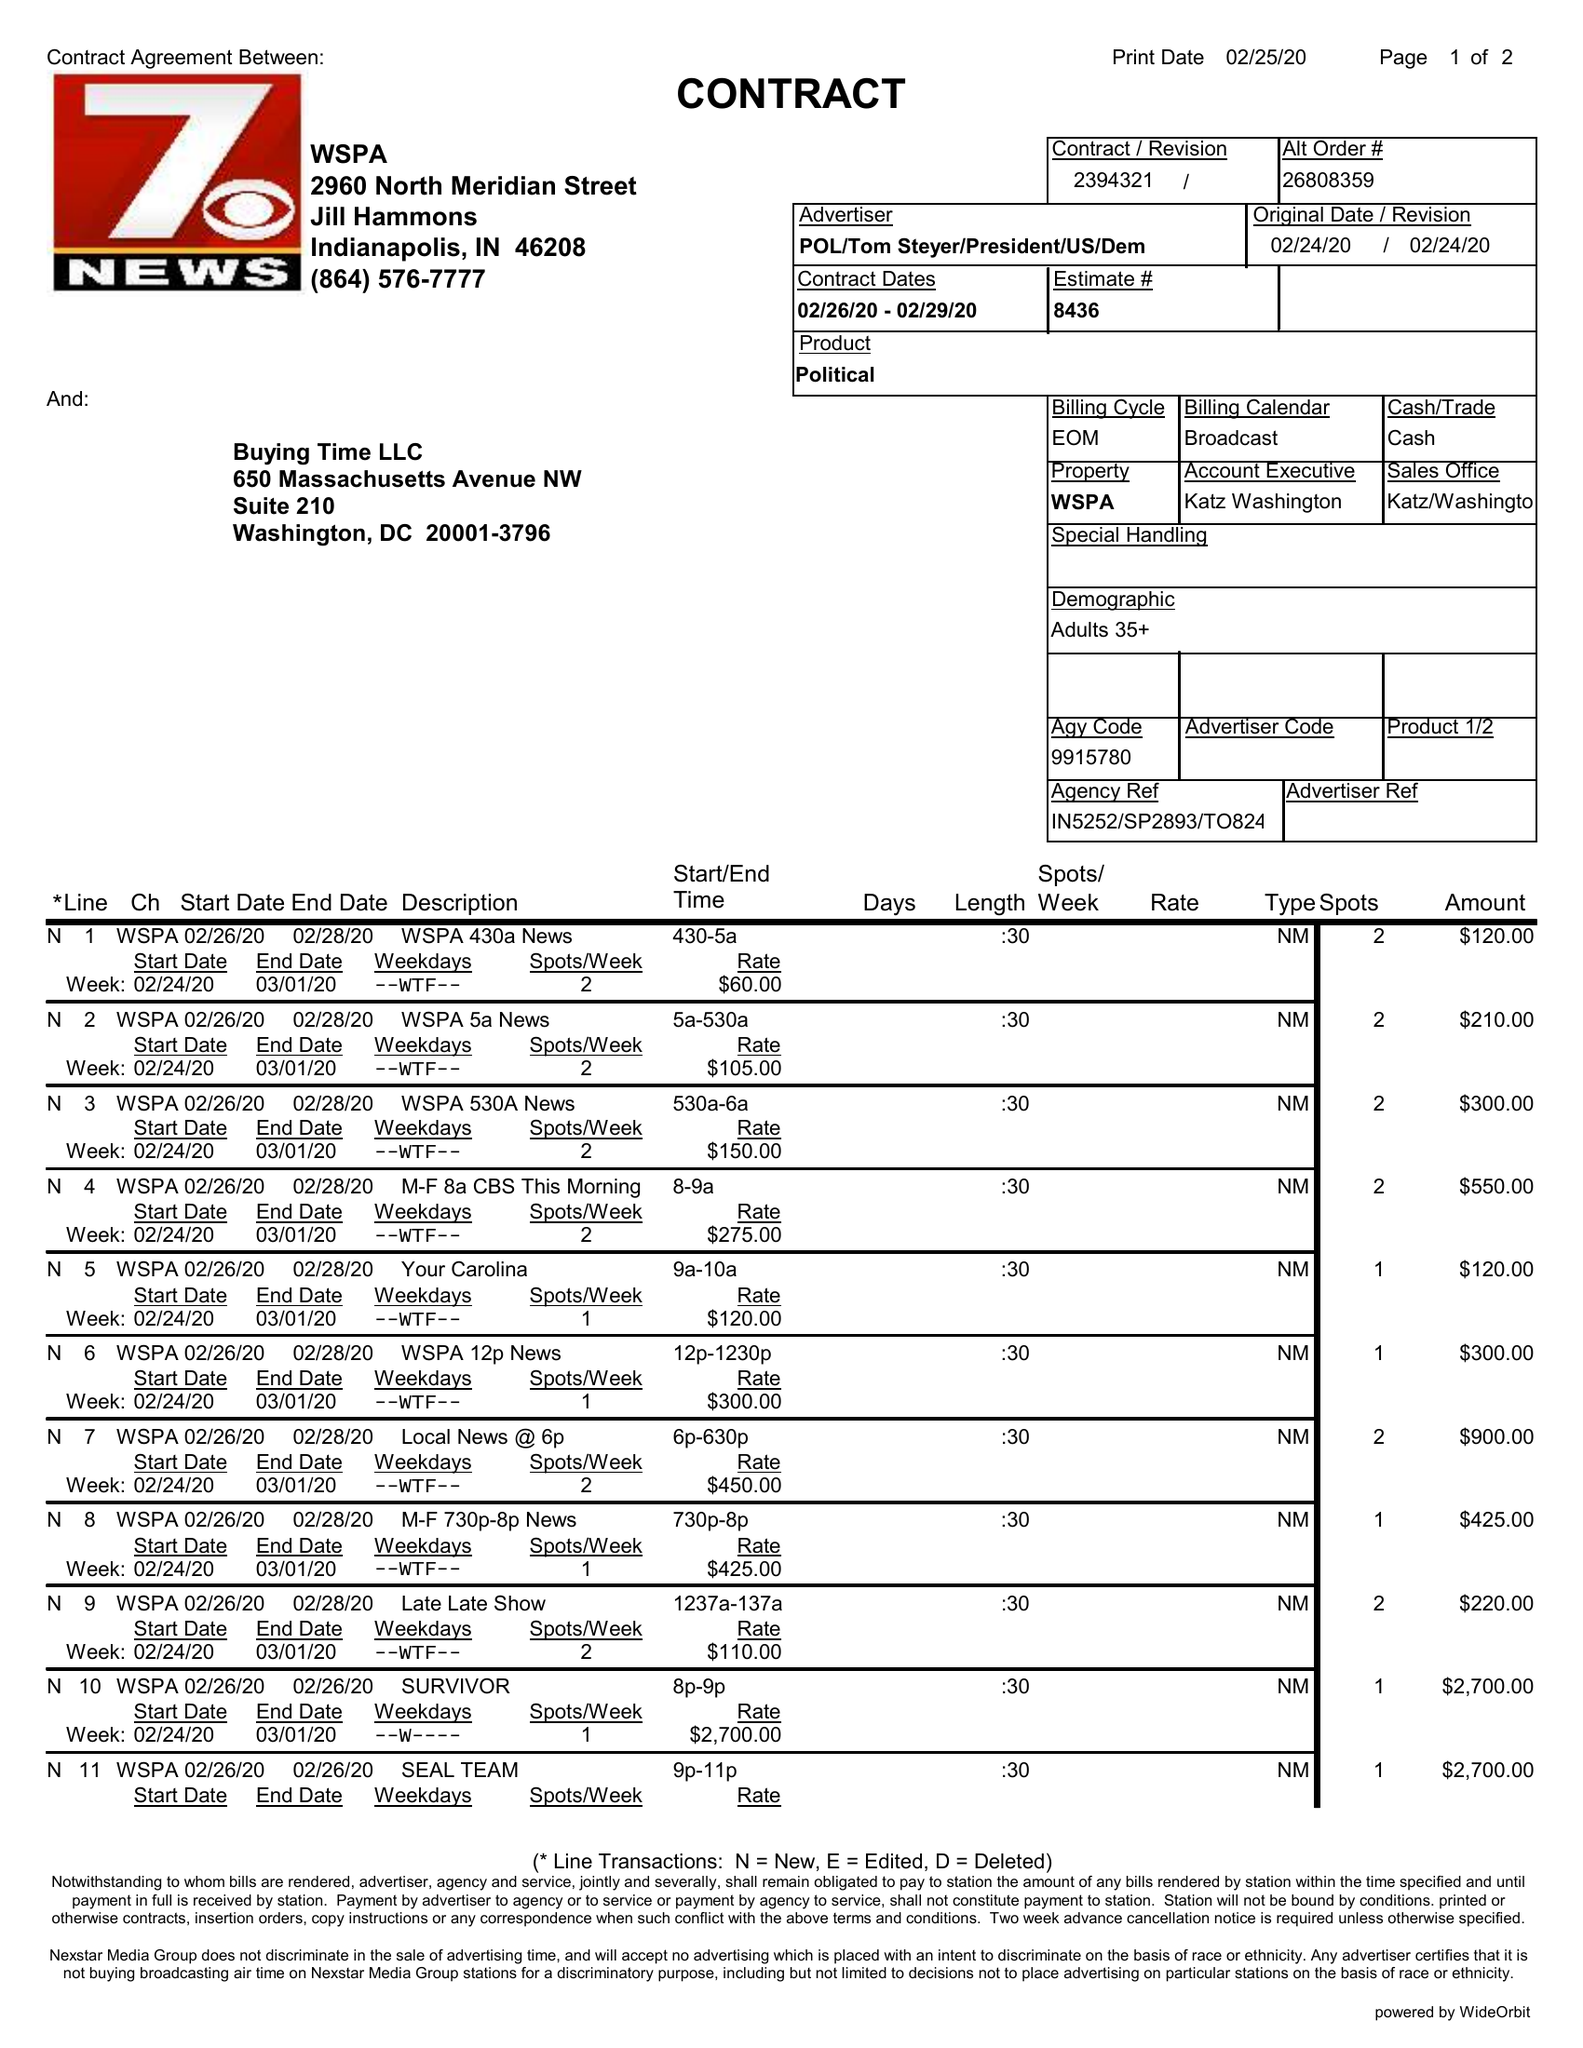What is the value for the gross_amount?
Answer the question using a single word or phrase. 16045.00 